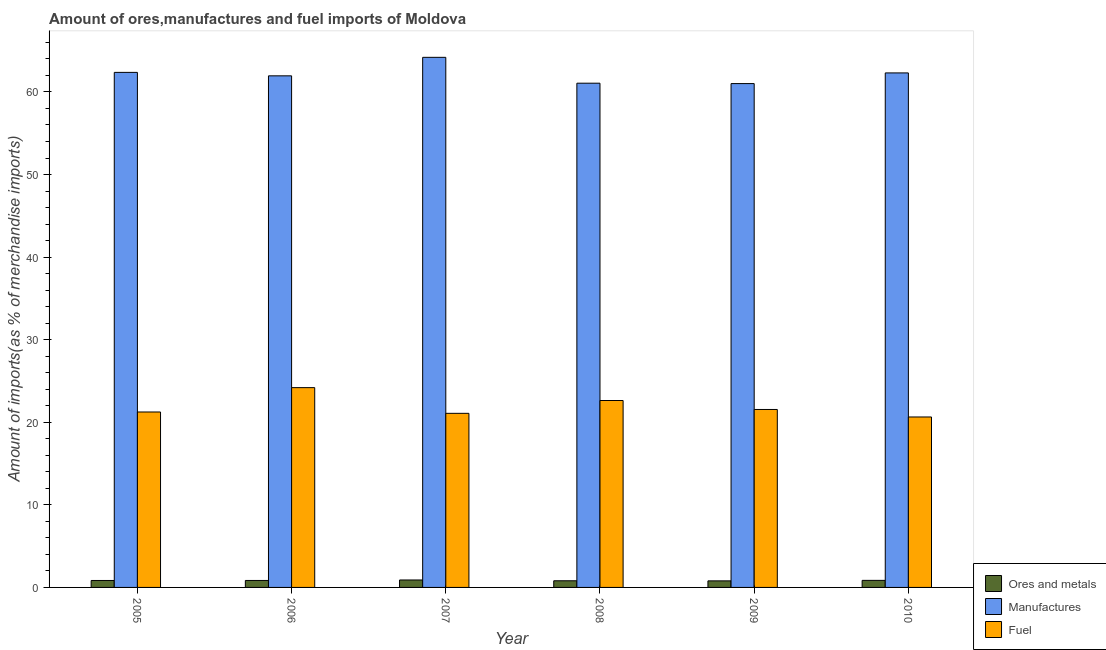How many different coloured bars are there?
Provide a succinct answer. 3. Are the number of bars per tick equal to the number of legend labels?
Offer a terse response. Yes. How many bars are there on the 3rd tick from the left?
Your response must be concise. 3. How many bars are there on the 6th tick from the right?
Give a very brief answer. 3. In how many cases, is the number of bars for a given year not equal to the number of legend labels?
Your answer should be very brief. 0. What is the percentage of fuel imports in 2006?
Your answer should be very brief. 24.19. Across all years, what is the maximum percentage of manufactures imports?
Your answer should be compact. 64.19. Across all years, what is the minimum percentage of ores and metals imports?
Provide a succinct answer. 0.79. In which year was the percentage of fuel imports maximum?
Your answer should be very brief. 2006. What is the total percentage of fuel imports in the graph?
Your answer should be very brief. 131.34. What is the difference between the percentage of fuel imports in 2008 and that in 2010?
Offer a very short reply. 1.99. What is the difference between the percentage of fuel imports in 2010 and the percentage of ores and metals imports in 2008?
Give a very brief answer. -1.99. What is the average percentage of ores and metals imports per year?
Offer a very short reply. 0.84. In how many years, is the percentage of ores and metals imports greater than 20 %?
Offer a very short reply. 0. What is the ratio of the percentage of manufactures imports in 2005 to that in 2006?
Your answer should be very brief. 1.01. Is the percentage of fuel imports in 2007 less than that in 2008?
Make the answer very short. Yes. Is the difference between the percentage of ores and metals imports in 2007 and 2008 greater than the difference between the percentage of manufactures imports in 2007 and 2008?
Your answer should be compact. No. What is the difference between the highest and the second highest percentage of fuel imports?
Provide a short and direct response. 1.56. What is the difference between the highest and the lowest percentage of manufactures imports?
Your response must be concise. 3.18. In how many years, is the percentage of ores and metals imports greater than the average percentage of ores and metals imports taken over all years?
Ensure brevity in your answer.  4. What does the 3rd bar from the left in 2007 represents?
Ensure brevity in your answer.  Fuel. What does the 3rd bar from the right in 2009 represents?
Provide a short and direct response. Ores and metals. Is it the case that in every year, the sum of the percentage of ores and metals imports and percentage of manufactures imports is greater than the percentage of fuel imports?
Make the answer very short. Yes. How many years are there in the graph?
Make the answer very short. 6. Where does the legend appear in the graph?
Your answer should be very brief. Bottom right. How are the legend labels stacked?
Provide a succinct answer. Vertical. What is the title of the graph?
Offer a very short reply. Amount of ores,manufactures and fuel imports of Moldova. What is the label or title of the X-axis?
Offer a terse response. Year. What is the label or title of the Y-axis?
Keep it short and to the point. Amount of imports(as % of merchandise imports). What is the Amount of imports(as % of merchandise imports) in Ores and metals in 2005?
Give a very brief answer. 0.84. What is the Amount of imports(as % of merchandise imports) of Manufactures in 2005?
Give a very brief answer. 62.37. What is the Amount of imports(as % of merchandise imports) of Fuel in 2005?
Make the answer very short. 21.24. What is the Amount of imports(as % of merchandise imports) in Ores and metals in 2006?
Ensure brevity in your answer.  0.84. What is the Amount of imports(as % of merchandise imports) in Manufactures in 2006?
Your response must be concise. 61.95. What is the Amount of imports(as % of merchandise imports) of Fuel in 2006?
Keep it short and to the point. 24.19. What is the Amount of imports(as % of merchandise imports) of Ores and metals in 2007?
Make the answer very short. 0.9. What is the Amount of imports(as % of merchandise imports) in Manufactures in 2007?
Your answer should be very brief. 64.19. What is the Amount of imports(as % of merchandise imports) of Fuel in 2007?
Keep it short and to the point. 21.08. What is the Amount of imports(as % of merchandise imports) of Ores and metals in 2008?
Keep it short and to the point. 0.8. What is the Amount of imports(as % of merchandise imports) in Manufactures in 2008?
Your response must be concise. 61.06. What is the Amount of imports(as % of merchandise imports) in Fuel in 2008?
Your response must be concise. 22.63. What is the Amount of imports(as % of merchandise imports) in Ores and metals in 2009?
Your answer should be compact. 0.79. What is the Amount of imports(as % of merchandise imports) of Manufactures in 2009?
Give a very brief answer. 61.01. What is the Amount of imports(as % of merchandise imports) in Fuel in 2009?
Keep it short and to the point. 21.55. What is the Amount of imports(as % of merchandise imports) of Ores and metals in 2010?
Keep it short and to the point. 0.85. What is the Amount of imports(as % of merchandise imports) in Manufactures in 2010?
Offer a very short reply. 62.3. What is the Amount of imports(as % of merchandise imports) of Fuel in 2010?
Ensure brevity in your answer.  20.64. Across all years, what is the maximum Amount of imports(as % of merchandise imports) in Ores and metals?
Ensure brevity in your answer.  0.9. Across all years, what is the maximum Amount of imports(as % of merchandise imports) in Manufactures?
Your answer should be compact. 64.19. Across all years, what is the maximum Amount of imports(as % of merchandise imports) of Fuel?
Provide a succinct answer. 24.19. Across all years, what is the minimum Amount of imports(as % of merchandise imports) of Ores and metals?
Offer a terse response. 0.79. Across all years, what is the minimum Amount of imports(as % of merchandise imports) in Manufactures?
Give a very brief answer. 61.01. Across all years, what is the minimum Amount of imports(as % of merchandise imports) of Fuel?
Ensure brevity in your answer.  20.64. What is the total Amount of imports(as % of merchandise imports) of Ores and metals in the graph?
Offer a very short reply. 5.04. What is the total Amount of imports(as % of merchandise imports) in Manufactures in the graph?
Provide a short and direct response. 372.89. What is the total Amount of imports(as % of merchandise imports) of Fuel in the graph?
Provide a succinct answer. 131.34. What is the difference between the Amount of imports(as % of merchandise imports) of Ores and metals in 2005 and that in 2006?
Make the answer very short. -0. What is the difference between the Amount of imports(as % of merchandise imports) of Manufactures in 2005 and that in 2006?
Provide a succinct answer. 0.42. What is the difference between the Amount of imports(as % of merchandise imports) of Fuel in 2005 and that in 2006?
Your response must be concise. -2.95. What is the difference between the Amount of imports(as % of merchandise imports) in Ores and metals in 2005 and that in 2007?
Your answer should be compact. -0.06. What is the difference between the Amount of imports(as % of merchandise imports) in Manufactures in 2005 and that in 2007?
Your answer should be compact. -1.82. What is the difference between the Amount of imports(as % of merchandise imports) in Fuel in 2005 and that in 2007?
Ensure brevity in your answer.  0.16. What is the difference between the Amount of imports(as % of merchandise imports) of Ores and metals in 2005 and that in 2008?
Provide a short and direct response. 0.04. What is the difference between the Amount of imports(as % of merchandise imports) in Manufactures in 2005 and that in 2008?
Provide a succinct answer. 1.31. What is the difference between the Amount of imports(as % of merchandise imports) in Fuel in 2005 and that in 2008?
Provide a succinct answer. -1.39. What is the difference between the Amount of imports(as % of merchandise imports) of Ores and metals in 2005 and that in 2009?
Your response must be concise. 0.05. What is the difference between the Amount of imports(as % of merchandise imports) of Manufactures in 2005 and that in 2009?
Your answer should be very brief. 1.36. What is the difference between the Amount of imports(as % of merchandise imports) of Fuel in 2005 and that in 2009?
Your answer should be compact. -0.3. What is the difference between the Amount of imports(as % of merchandise imports) of Ores and metals in 2005 and that in 2010?
Make the answer very short. -0.01. What is the difference between the Amount of imports(as % of merchandise imports) of Manufactures in 2005 and that in 2010?
Provide a short and direct response. 0.06. What is the difference between the Amount of imports(as % of merchandise imports) of Fuel in 2005 and that in 2010?
Keep it short and to the point. 0.6. What is the difference between the Amount of imports(as % of merchandise imports) of Ores and metals in 2006 and that in 2007?
Your response must be concise. -0.06. What is the difference between the Amount of imports(as % of merchandise imports) in Manufactures in 2006 and that in 2007?
Your response must be concise. -2.24. What is the difference between the Amount of imports(as % of merchandise imports) in Fuel in 2006 and that in 2007?
Your answer should be compact. 3.11. What is the difference between the Amount of imports(as % of merchandise imports) in Ores and metals in 2006 and that in 2008?
Offer a terse response. 0.04. What is the difference between the Amount of imports(as % of merchandise imports) in Manufactures in 2006 and that in 2008?
Provide a short and direct response. 0.89. What is the difference between the Amount of imports(as % of merchandise imports) of Fuel in 2006 and that in 2008?
Your answer should be very brief. 1.56. What is the difference between the Amount of imports(as % of merchandise imports) in Ores and metals in 2006 and that in 2009?
Your answer should be compact. 0.05. What is the difference between the Amount of imports(as % of merchandise imports) of Manufactures in 2006 and that in 2009?
Provide a short and direct response. 0.94. What is the difference between the Amount of imports(as % of merchandise imports) in Fuel in 2006 and that in 2009?
Ensure brevity in your answer.  2.65. What is the difference between the Amount of imports(as % of merchandise imports) of Ores and metals in 2006 and that in 2010?
Make the answer very short. -0.01. What is the difference between the Amount of imports(as % of merchandise imports) in Manufactures in 2006 and that in 2010?
Offer a terse response. -0.35. What is the difference between the Amount of imports(as % of merchandise imports) of Fuel in 2006 and that in 2010?
Your answer should be compact. 3.55. What is the difference between the Amount of imports(as % of merchandise imports) in Ores and metals in 2007 and that in 2008?
Your answer should be very brief. 0.1. What is the difference between the Amount of imports(as % of merchandise imports) in Manufactures in 2007 and that in 2008?
Your response must be concise. 3.13. What is the difference between the Amount of imports(as % of merchandise imports) of Fuel in 2007 and that in 2008?
Offer a very short reply. -1.55. What is the difference between the Amount of imports(as % of merchandise imports) in Ores and metals in 2007 and that in 2009?
Your response must be concise. 0.11. What is the difference between the Amount of imports(as % of merchandise imports) in Manufactures in 2007 and that in 2009?
Your response must be concise. 3.18. What is the difference between the Amount of imports(as % of merchandise imports) in Fuel in 2007 and that in 2009?
Give a very brief answer. -0.47. What is the difference between the Amount of imports(as % of merchandise imports) of Ores and metals in 2007 and that in 2010?
Give a very brief answer. 0.05. What is the difference between the Amount of imports(as % of merchandise imports) of Manufactures in 2007 and that in 2010?
Your answer should be compact. 1.89. What is the difference between the Amount of imports(as % of merchandise imports) in Fuel in 2007 and that in 2010?
Your answer should be very brief. 0.44. What is the difference between the Amount of imports(as % of merchandise imports) of Ores and metals in 2008 and that in 2009?
Offer a very short reply. 0.01. What is the difference between the Amount of imports(as % of merchandise imports) of Manufactures in 2008 and that in 2009?
Keep it short and to the point. 0.05. What is the difference between the Amount of imports(as % of merchandise imports) in Fuel in 2008 and that in 2009?
Your answer should be compact. 1.09. What is the difference between the Amount of imports(as % of merchandise imports) in Ores and metals in 2008 and that in 2010?
Offer a very short reply. -0.05. What is the difference between the Amount of imports(as % of merchandise imports) in Manufactures in 2008 and that in 2010?
Your answer should be compact. -1.24. What is the difference between the Amount of imports(as % of merchandise imports) of Fuel in 2008 and that in 2010?
Offer a very short reply. 1.99. What is the difference between the Amount of imports(as % of merchandise imports) of Ores and metals in 2009 and that in 2010?
Provide a short and direct response. -0.06. What is the difference between the Amount of imports(as % of merchandise imports) in Manufactures in 2009 and that in 2010?
Your answer should be compact. -1.29. What is the difference between the Amount of imports(as % of merchandise imports) of Fuel in 2009 and that in 2010?
Your response must be concise. 0.91. What is the difference between the Amount of imports(as % of merchandise imports) of Ores and metals in 2005 and the Amount of imports(as % of merchandise imports) of Manufactures in 2006?
Your response must be concise. -61.11. What is the difference between the Amount of imports(as % of merchandise imports) in Ores and metals in 2005 and the Amount of imports(as % of merchandise imports) in Fuel in 2006?
Your answer should be compact. -23.35. What is the difference between the Amount of imports(as % of merchandise imports) of Manufactures in 2005 and the Amount of imports(as % of merchandise imports) of Fuel in 2006?
Make the answer very short. 38.17. What is the difference between the Amount of imports(as % of merchandise imports) in Ores and metals in 2005 and the Amount of imports(as % of merchandise imports) in Manufactures in 2007?
Your answer should be compact. -63.35. What is the difference between the Amount of imports(as % of merchandise imports) in Ores and metals in 2005 and the Amount of imports(as % of merchandise imports) in Fuel in 2007?
Give a very brief answer. -20.24. What is the difference between the Amount of imports(as % of merchandise imports) in Manufactures in 2005 and the Amount of imports(as % of merchandise imports) in Fuel in 2007?
Ensure brevity in your answer.  41.29. What is the difference between the Amount of imports(as % of merchandise imports) in Ores and metals in 2005 and the Amount of imports(as % of merchandise imports) in Manufactures in 2008?
Give a very brief answer. -60.22. What is the difference between the Amount of imports(as % of merchandise imports) of Ores and metals in 2005 and the Amount of imports(as % of merchandise imports) of Fuel in 2008?
Provide a short and direct response. -21.79. What is the difference between the Amount of imports(as % of merchandise imports) in Manufactures in 2005 and the Amount of imports(as % of merchandise imports) in Fuel in 2008?
Your answer should be very brief. 39.73. What is the difference between the Amount of imports(as % of merchandise imports) of Ores and metals in 2005 and the Amount of imports(as % of merchandise imports) of Manufactures in 2009?
Offer a very short reply. -60.17. What is the difference between the Amount of imports(as % of merchandise imports) of Ores and metals in 2005 and the Amount of imports(as % of merchandise imports) of Fuel in 2009?
Provide a short and direct response. -20.71. What is the difference between the Amount of imports(as % of merchandise imports) in Manufactures in 2005 and the Amount of imports(as % of merchandise imports) in Fuel in 2009?
Provide a succinct answer. 40.82. What is the difference between the Amount of imports(as % of merchandise imports) of Ores and metals in 2005 and the Amount of imports(as % of merchandise imports) of Manufactures in 2010?
Provide a succinct answer. -61.46. What is the difference between the Amount of imports(as % of merchandise imports) in Ores and metals in 2005 and the Amount of imports(as % of merchandise imports) in Fuel in 2010?
Your answer should be very brief. -19.8. What is the difference between the Amount of imports(as % of merchandise imports) of Manufactures in 2005 and the Amount of imports(as % of merchandise imports) of Fuel in 2010?
Provide a short and direct response. 41.73. What is the difference between the Amount of imports(as % of merchandise imports) in Ores and metals in 2006 and the Amount of imports(as % of merchandise imports) in Manufactures in 2007?
Give a very brief answer. -63.35. What is the difference between the Amount of imports(as % of merchandise imports) in Ores and metals in 2006 and the Amount of imports(as % of merchandise imports) in Fuel in 2007?
Provide a short and direct response. -20.24. What is the difference between the Amount of imports(as % of merchandise imports) of Manufactures in 2006 and the Amount of imports(as % of merchandise imports) of Fuel in 2007?
Give a very brief answer. 40.87. What is the difference between the Amount of imports(as % of merchandise imports) in Ores and metals in 2006 and the Amount of imports(as % of merchandise imports) in Manufactures in 2008?
Your answer should be very brief. -60.22. What is the difference between the Amount of imports(as % of merchandise imports) of Ores and metals in 2006 and the Amount of imports(as % of merchandise imports) of Fuel in 2008?
Your answer should be compact. -21.79. What is the difference between the Amount of imports(as % of merchandise imports) in Manufactures in 2006 and the Amount of imports(as % of merchandise imports) in Fuel in 2008?
Ensure brevity in your answer.  39.32. What is the difference between the Amount of imports(as % of merchandise imports) in Ores and metals in 2006 and the Amount of imports(as % of merchandise imports) in Manufactures in 2009?
Offer a very short reply. -60.17. What is the difference between the Amount of imports(as % of merchandise imports) in Ores and metals in 2006 and the Amount of imports(as % of merchandise imports) in Fuel in 2009?
Keep it short and to the point. -20.7. What is the difference between the Amount of imports(as % of merchandise imports) of Manufactures in 2006 and the Amount of imports(as % of merchandise imports) of Fuel in 2009?
Provide a short and direct response. 40.4. What is the difference between the Amount of imports(as % of merchandise imports) in Ores and metals in 2006 and the Amount of imports(as % of merchandise imports) in Manufactures in 2010?
Give a very brief answer. -61.46. What is the difference between the Amount of imports(as % of merchandise imports) in Ores and metals in 2006 and the Amount of imports(as % of merchandise imports) in Fuel in 2010?
Provide a succinct answer. -19.8. What is the difference between the Amount of imports(as % of merchandise imports) of Manufactures in 2006 and the Amount of imports(as % of merchandise imports) of Fuel in 2010?
Your response must be concise. 41.31. What is the difference between the Amount of imports(as % of merchandise imports) of Ores and metals in 2007 and the Amount of imports(as % of merchandise imports) of Manufactures in 2008?
Your answer should be compact. -60.16. What is the difference between the Amount of imports(as % of merchandise imports) in Ores and metals in 2007 and the Amount of imports(as % of merchandise imports) in Fuel in 2008?
Offer a very short reply. -21.73. What is the difference between the Amount of imports(as % of merchandise imports) of Manufactures in 2007 and the Amount of imports(as % of merchandise imports) of Fuel in 2008?
Your response must be concise. 41.56. What is the difference between the Amount of imports(as % of merchandise imports) of Ores and metals in 2007 and the Amount of imports(as % of merchandise imports) of Manufactures in 2009?
Give a very brief answer. -60.11. What is the difference between the Amount of imports(as % of merchandise imports) in Ores and metals in 2007 and the Amount of imports(as % of merchandise imports) in Fuel in 2009?
Make the answer very short. -20.65. What is the difference between the Amount of imports(as % of merchandise imports) in Manufactures in 2007 and the Amount of imports(as % of merchandise imports) in Fuel in 2009?
Offer a very short reply. 42.64. What is the difference between the Amount of imports(as % of merchandise imports) in Ores and metals in 2007 and the Amount of imports(as % of merchandise imports) in Manufactures in 2010?
Offer a very short reply. -61.4. What is the difference between the Amount of imports(as % of merchandise imports) of Ores and metals in 2007 and the Amount of imports(as % of merchandise imports) of Fuel in 2010?
Provide a succinct answer. -19.74. What is the difference between the Amount of imports(as % of merchandise imports) in Manufactures in 2007 and the Amount of imports(as % of merchandise imports) in Fuel in 2010?
Your answer should be compact. 43.55. What is the difference between the Amount of imports(as % of merchandise imports) of Ores and metals in 2008 and the Amount of imports(as % of merchandise imports) of Manufactures in 2009?
Your answer should be very brief. -60.21. What is the difference between the Amount of imports(as % of merchandise imports) in Ores and metals in 2008 and the Amount of imports(as % of merchandise imports) in Fuel in 2009?
Offer a terse response. -20.74. What is the difference between the Amount of imports(as % of merchandise imports) in Manufactures in 2008 and the Amount of imports(as % of merchandise imports) in Fuel in 2009?
Your answer should be compact. 39.51. What is the difference between the Amount of imports(as % of merchandise imports) in Ores and metals in 2008 and the Amount of imports(as % of merchandise imports) in Manufactures in 2010?
Your answer should be very brief. -61.5. What is the difference between the Amount of imports(as % of merchandise imports) in Ores and metals in 2008 and the Amount of imports(as % of merchandise imports) in Fuel in 2010?
Your response must be concise. -19.84. What is the difference between the Amount of imports(as % of merchandise imports) of Manufactures in 2008 and the Amount of imports(as % of merchandise imports) of Fuel in 2010?
Ensure brevity in your answer.  40.42. What is the difference between the Amount of imports(as % of merchandise imports) of Ores and metals in 2009 and the Amount of imports(as % of merchandise imports) of Manufactures in 2010?
Give a very brief answer. -61.51. What is the difference between the Amount of imports(as % of merchandise imports) of Ores and metals in 2009 and the Amount of imports(as % of merchandise imports) of Fuel in 2010?
Provide a succinct answer. -19.85. What is the difference between the Amount of imports(as % of merchandise imports) of Manufactures in 2009 and the Amount of imports(as % of merchandise imports) of Fuel in 2010?
Keep it short and to the point. 40.37. What is the average Amount of imports(as % of merchandise imports) of Ores and metals per year?
Keep it short and to the point. 0.84. What is the average Amount of imports(as % of merchandise imports) in Manufactures per year?
Keep it short and to the point. 62.15. What is the average Amount of imports(as % of merchandise imports) in Fuel per year?
Your response must be concise. 21.89. In the year 2005, what is the difference between the Amount of imports(as % of merchandise imports) of Ores and metals and Amount of imports(as % of merchandise imports) of Manufactures?
Offer a very short reply. -61.53. In the year 2005, what is the difference between the Amount of imports(as % of merchandise imports) of Ores and metals and Amount of imports(as % of merchandise imports) of Fuel?
Keep it short and to the point. -20.4. In the year 2005, what is the difference between the Amount of imports(as % of merchandise imports) of Manufactures and Amount of imports(as % of merchandise imports) of Fuel?
Your answer should be compact. 41.12. In the year 2006, what is the difference between the Amount of imports(as % of merchandise imports) of Ores and metals and Amount of imports(as % of merchandise imports) of Manufactures?
Your answer should be very brief. -61.11. In the year 2006, what is the difference between the Amount of imports(as % of merchandise imports) in Ores and metals and Amount of imports(as % of merchandise imports) in Fuel?
Offer a very short reply. -23.35. In the year 2006, what is the difference between the Amount of imports(as % of merchandise imports) of Manufactures and Amount of imports(as % of merchandise imports) of Fuel?
Keep it short and to the point. 37.76. In the year 2007, what is the difference between the Amount of imports(as % of merchandise imports) in Ores and metals and Amount of imports(as % of merchandise imports) in Manufactures?
Keep it short and to the point. -63.29. In the year 2007, what is the difference between the Amount of imports(as % of merchandise imports) of Ores and metals and Amount of imports(as % of merchandise imports) of Fuel?
Provide a succinct answer. -20.18. In the year 2007, what is the difference between the Amount of imports(as % of merchandise imports) in Manufactures and Amount of imports(as % of merchandise imports) in Fuel?
Make the answer very short. 43.11. In the year 2008, what is the difference between the Amount of imports(as % of merchandise imports) in Ores and metals and Amount of imports(as % of merchandise imports) in Manufactures?
Keep it short and to the point. -60.25. In the year 2008, what is the difference between the Amount of imports(as % of merchandise imports) of Ores and metals and Amount of imports(as % of merchandise imports) of Fuel?
Ensure brevity in your answer.  -21.83. In the year 2008, what is the difference between the Amount of imports(as % of merchandise imports) in Manufactures and Amount of imports(as % of merchandise imports) in Fuel?
Your answer should be very brief. 38.43. In the year 2009, what is the difference between the Amount of imports(as % of merchandise imports) in Ores and metals and Amount of imports(as % of merchandise imports) in Manufactures?
Make the answer very short. -60.22. In the year 2009, what is the difference between the Amount of imports(as % of merchandise imports) of Ores and metals and Amount of imports(as % of merchandise imports) of Fuel?
Give a very brief answer. -20.75. In the year 2009, what is the difference between the Amount of imports(as % of merchandise imports) in Manufactures and Amount of imports(as % of merchandise imports) in Fuel?
Make the answer very short. 39.46. In the year 2010, what is the difference between the Amount of imports(as % of merchandise imports) of Ores and metals and Amount of imports(as % of merchandise imports) of Manufactures?
Your answer should be compact. -61.45. In the year 2010, what is the difference between the Amount of imports(as % of merchandise imports) in Ores and metals and Amount of imports(as % of merchandise imports) in Fuel?
Your response must be concise. -19.79. In the year 2010, what is the difference between the Amount of imports(as % of merchandise imports) of Manufactures and Amount of imports(as % of merchandise imports) of Fuel?
Provide a short and direct response. 41.66. What is the ratio of the Amount of imports(as % of merchandise imports) in Manufactures in 2005 to that in 2006?
Your answer should be compact. 1.01. What is the ratio of the Amount of imports(as % of merchandise imports) of Fuel in 2005 to that in 2006?
Offer a very short reply. 0.88. What is the ratio of the Amount of imports(as % of merchandise imports) in Ores and metals in 2005 to that in 2007?
Provide a succinct answer. 0.93. What is the ratio of the Amount of imports(as % of merchandise imports) in Manufactures in 2005 to that in 2007?
Your response must be concise. 0.97. What is the ratio of the Amount of imports(as % of merchandise imports) in Fuel in 2005 to that in 2007?
Make the answer very short. 1.01. What is the ratio of the Amount of imports(as % of merchandise imports) in Ores and metals in 2005 to that in 2008?
Provide a succinct answer. 1.05. What is the ratio of the Amount of imports(as % of merchandise imports) of Manufactures in 2005 to that in 2008?
Offer a very short reply. 1.02. What is the ratio of the Amount of imports(as % of merchandise imports) of Fuel in 2005 to that in 2008?
Provide a succinct answer. 0.94. What is the ratio of the Amount of imports(as % of merchandise imports) in Ores and metals in 2005 to that in 2009?
Offer a very short reply. 1.06. What is the ratio of the Amount of imports(as % of merchandise imports) of Manufactures in 2005 to that in 2009?
Your response must be concise. 1.02. What is the ratio of the Amount of imports(as % of merchandise imports) of Fuel in 2005 to that in 2009?
Offer a terse response. 0.99. What is the ratio of the Amount of imports(as % of merchandise imports) in Ores and metals in 2005 to that in 2010?
Offer a very short reply. 0.98. What is the ratio of the Amount of imports(as % of merchandise imports) in Manufactures in 2005 to that in 2010?
Ensure brevity in your answer.  1. What is the ratio of the Amount of imports(as % of merchandise imports) of Fuel in 2005 to that in 2010?
Provide a succinct answer. 1.03. What is the ratio of the Amount of imports(as % of merchandise imports) of Ores and metals in 2006 to that in 2007?
Your answer should be very brief. 0.94. What is the ratio of the Amount of imports(as % of merchandise imports) of Manufactures in 2006 to that in 2007?
Make the answer very short. 0.97. What is the ratio of the Amount of imports(as % of merchandise imports) in Fuel in 2006 to that in 2007?
Ensure brevity in your answer.  1.15. What is the ratio of the Amount of imports(as % of merchandise imports) in Ores and metals in 2006 to that in 2008?
Make the answer very short. 1.05. What is the ratio of the Amount of imports(as % of merchandise imports) in Manufactures in 2006 to that in 2008?
Provide a succinct answer. 1.01. What is the ratio of the Amount of imports(as % of merchandise imports) of Fuel in 2006 to that in 2008?
Your response must be concise. 1.07. What is the ratio of the Amount of imports(as % of merchandise imports) in Ores and metals in 2006 to that in 2009?
Ensure brevity in your answer.  1.06. What is the ratio of the Amount of imports(as % of merchandise imports) in Manufactures in 2006 to that in 2009?
Make the answer very short. 1.02. What is the ratio of the Amount of imports(as % of merchandise imports) in Fuel in 2006 to that in 2009?
Keep it short and to the point. 1.12. What is the ratio of the Amount of imports(as % of merchandise imports) of Ores and metals in 2006 to that in 2010?
Your answer should be compact. 0.99. What is the ratio of the Amount of imports(as % of merchandise imports) of Manufactures in 2006 to that in 2010?
Ensure brevity in your answer.  0.99. What is the ratio of the Amount of imports(as % of merchandise imports) in Fuel in 2006 to that in 2010?
Make the answer very short. 1.17. What is the ratio of the Amount of imports(as % of merchandise imports) of Ores and metals in 2007 to that in 2008?
Your response must be concise. 1.12. What is the ratio of the Amount of imports(as % of merchandise imports) in Manufactures in 2007 to that in 2008?
Keep it short and to the point. 1.05. What is the ratio of the Amount of imports(as % of merchandise imports) of Fuel in 2007 to that in 2008?
Keep it short and to the point. 0.93. What is the ratio of the Amount of imports(as % of merchandise imports) in Ores and metals in 2007 to that in 2009?
Give a very brief answer. 1.14. What is the ratio of the Amount of imports(as % of merchandise imports) of Manufactures in 2007 to that in 2009?
Offer a very short reply. 1.05. What is the ratio of the Amount of imports(as % of merchandise imports) in Fuel in 2007 to that in 2009?
Keep it short and to the point. 0.98. What is the ratio of the Amount of imports(as % of merchandise imports) of Ores and metals in 2007 to that in 2010?
Your answer should be compact. 1.06. What is the ratio of the Amount of imports(as % of merchandise imports) in Manufactures in 2007 to that in 2010?
Make the answer very short. 1.03. What is the ratio of the Amount of imports(as % of merchandise imports) of Fuel in 2007 to that in 2010?
Offer a terse response. 1.02. What is the ratio of the Amount of imports(as % of merchandise imports) of Ores and metals in 2008 to that in 2009?
Offer a very short reply. 1.01. What is the ratio of the Amount of imports(as % of merchandise imports) in Manufactures in 2008 to that in 2009?
Your response must be concise. 1. What is the ratio of the Amount of imports(as % of merchandise imports) of Fuel in 2008 to that in 2009?
Your response must be concise. 1.05. What is the ratio of the Amount of imports(as % of merchandise imports) of Ores and metals in 2008 to that in 2010?
Your answer should be compact. 0.94. What is the ratio of the Amount of imports(as % of merchandise imports) of Manufactures in 2008 to that in 2010?
Your answer should be very brief. 0.98. What is the ratio of the Amount of imports(as % of merchandise imports) of Fuel in 2008 to that in 2010?
Ensure brevity in your answer.  1.1. What is the ratio of the Amount of imports(as % of merchandise imports) of Ores and metals in 2009 to that in 2010?
Make the answer very short. 0.93. What is the ratio of the Amount of imports(as % of merchandise imports) in Manufactures in 2009 to that in 2010?
Provide a succinct answer. 0.98. What is the ratio of the Amount of imports(as % of merchandise imports) in Fuel in 2009 to that in 2010?
Make the answer very short. 1.04. What is the difference between the highest and the second highest Amount of imports(as % of merchandise imports) in Ores and metals?
Provide a short and direct response. 0.05. What is the difference between the highest and the second highest Amount of imports(as % of merchandise imports) in Manufactures?
Make the answer very short. 1.82. What is the difference between the highest and the second highest Amount of imports(as % of merchandise imports) of Fuel?
Your answer should be very brief. 1.56. What is the difference between the highest and the lowest Amount of imports(as % of merchandise imports) in Ores and metals?
Keep it short and to the point. 0.11. What is the difference between the highest and the lowest Amount of imports(as % of merchandise imports) of Manufactures?
Offer a terse response. 3.18. What is the difference between the highest and the lowest Amount of imports(as % of merchandise imports) in Fuel?
Provide a short and direct response. 3.55. 